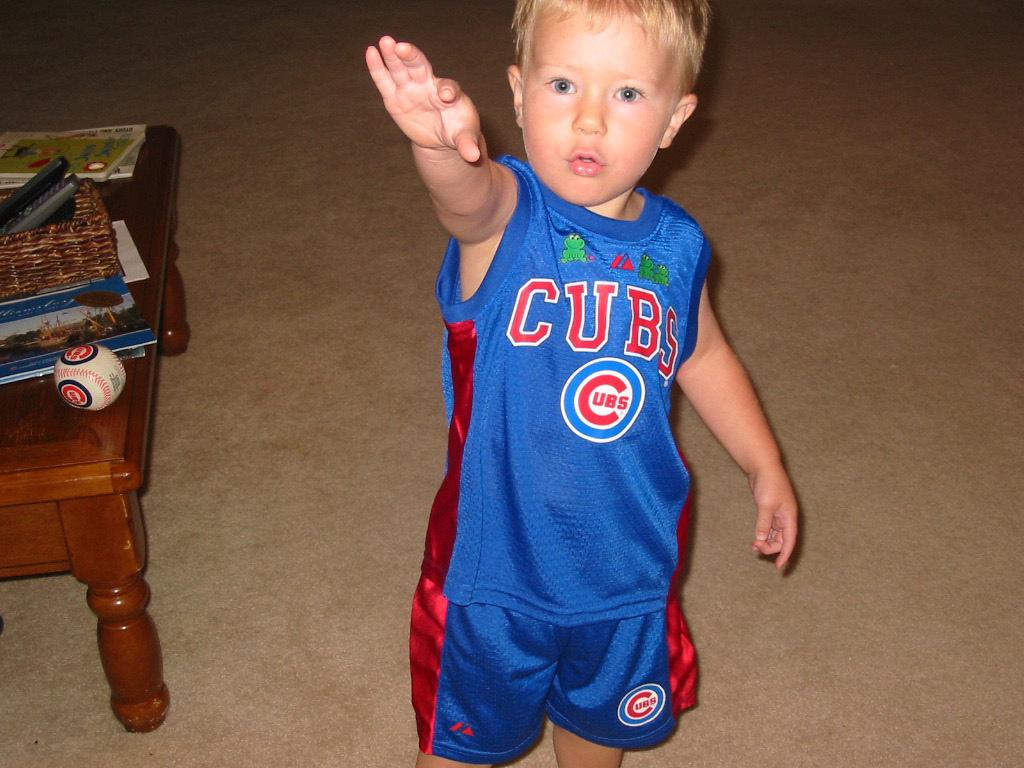What team is on the toddlers shirt?
Give a very brief answer. Cubs. 